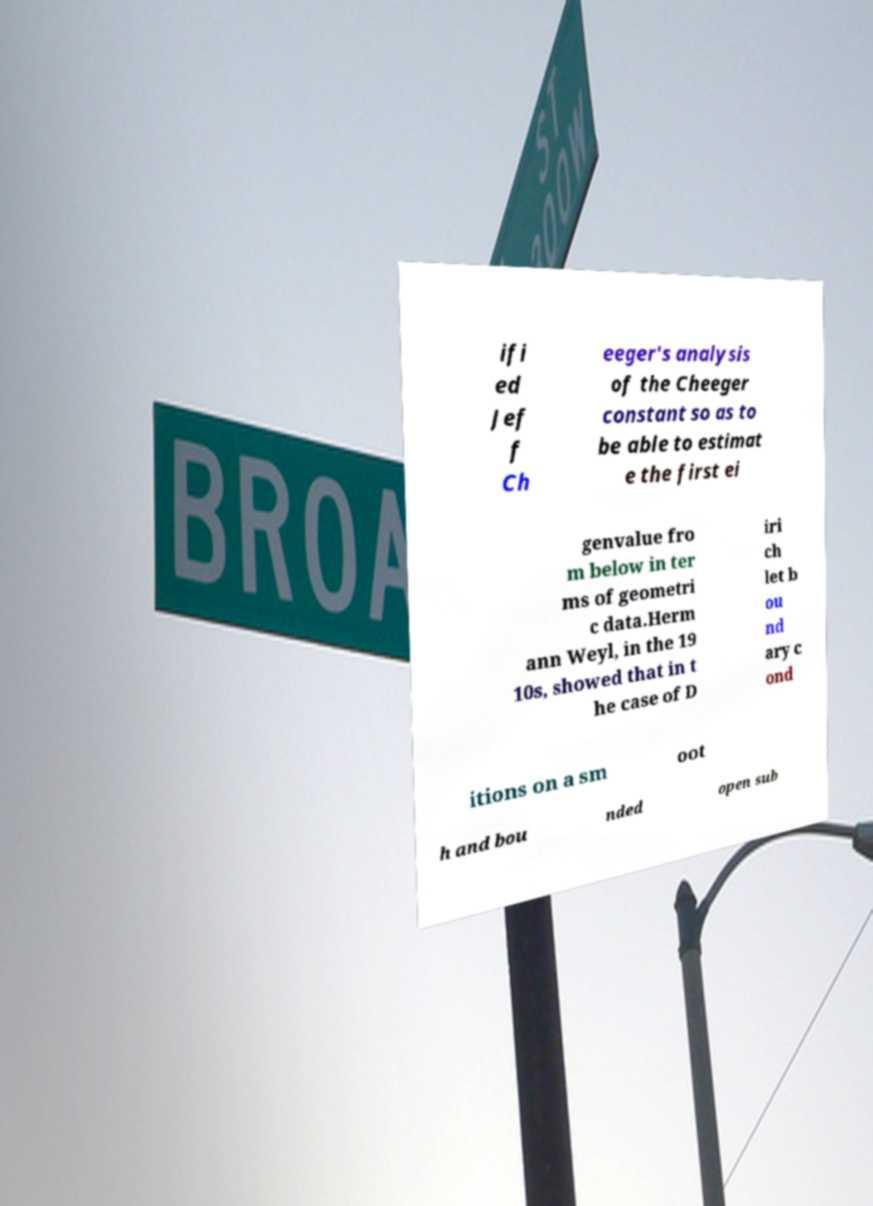Can you read and provide the text displayed in the image?This photo seems to have some interesting text. Can you extract and type it out for me? ifi ed Jef f Ch eeger's analysis of the Cheeger constant so as to be able to estimat e the first ei genvalue fro m below in ter ms of geometri c data.Herm ann Weyl, in the 19 10s, showed that in t he case of D iri ch let b ou nd ary c ond itions on a sm oot h and bou nded open sub 